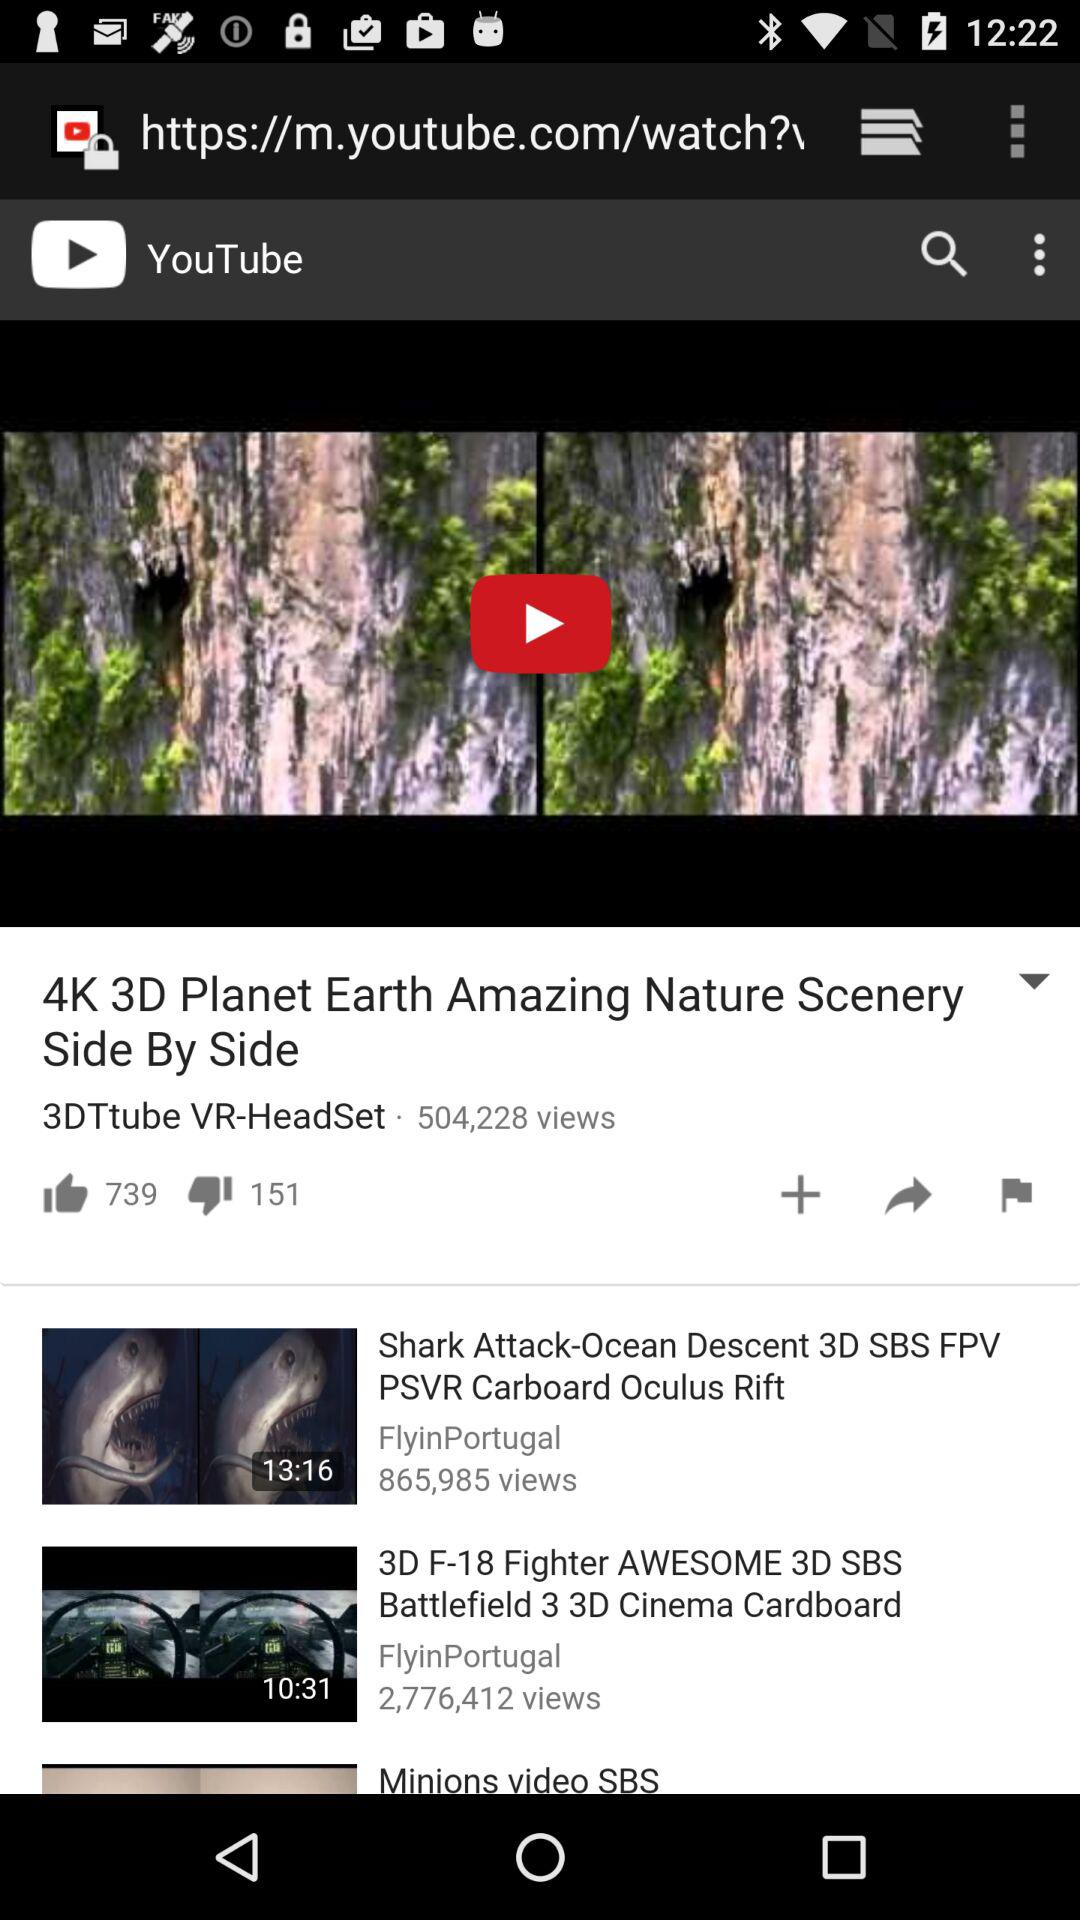How many dislikes on the "4K 3D Planet Earth Amazing Nature Scenery Side by Side" video? There are 151 dislikes. 